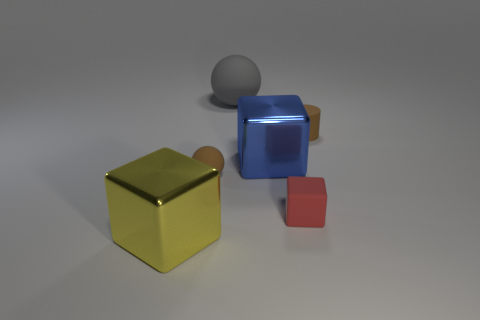Subtract all small red rubber blocks. How many blocks are left? 2 Subtract 1 cylinders. How many cylinders are left? 0 Subtract all gray balls. How many balls are left? 1 Add 3 rubber spheres. How many objects exist? 9 Subtract all cylinders. How many objects are left? 5 Subtract all purple cylinders. How many brown spheres are left? 1 Subtract all large spheres. Subtract all brown rubber balls. How many objects are left? 4 Add 3 big blocks. How many big blocks are left? 5 Add 5 small objects. How many small objects exist? 8 Subtract 0 gray cylinders. How many objects are left? 6 